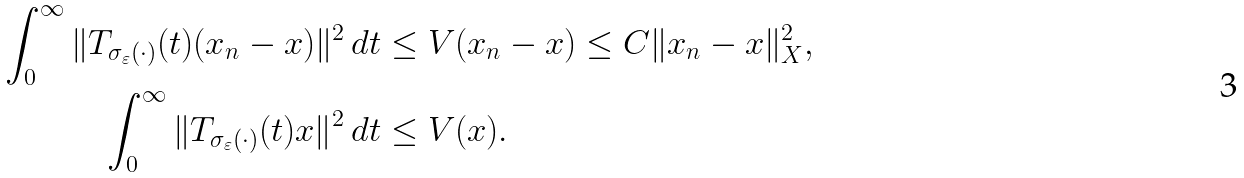<formula> <loc_0><loc_0><loc_500><loc_500>\int _ { 0 } ^ { \infty } \| T _ { \sigma _ { \varepsilon } ( \cdot ) } ( t ) ( x _ { n } - x ) \| ^ { 2 } \, d t & \leq V ( x _ { n } - x ) \leq C \| x _ { n } - x \| _ { X } ^ { 2 } , \\ \int _ { 0 } ^ { \infty } \| T _ { \sigma _ { \varepsilon } ( \cdot ) } ( t ) x \| ^ { 2 } \, d t & \leq V ( x ) .</formula> 